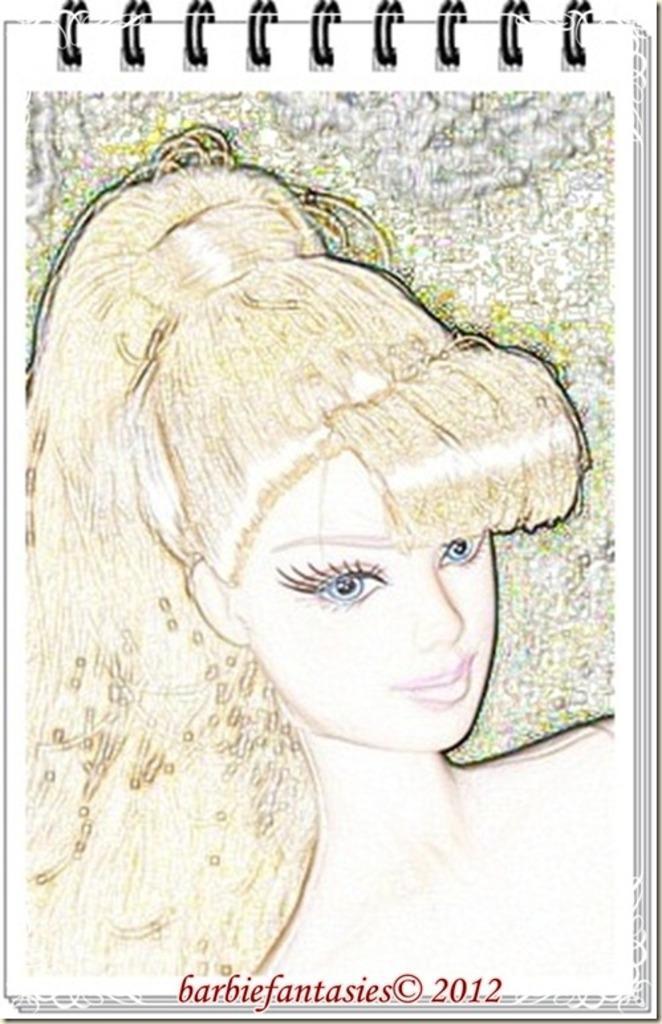Can you describe this image briefly? In this image I can see a sketch. And the sketch is of, a doll on the paper of a notepad. Also there is a watermark at the bottom of the image. 